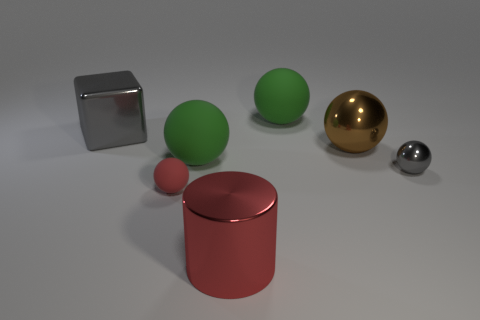Subtract all brown spheres. How many spheres are left? 4 Subtract all small matte balls. How many balls are left? 4 Subtract all purple spheres. Subtract all brown cylinders. How many spheres are left? 5 Add 1 green matte spheres. How many objects exist? 8 Subtract all balls. How many objects are left? 2 Add 3 big green matte balls. How many big green matte balls are left? 5 Add 3 green rubber objects. How many green rubber objects exist? 5 Subtract 0 green cubes. How many objects are left? 7 Subtract all balls. Subtract all red cylinders. How many objects are left? 1 